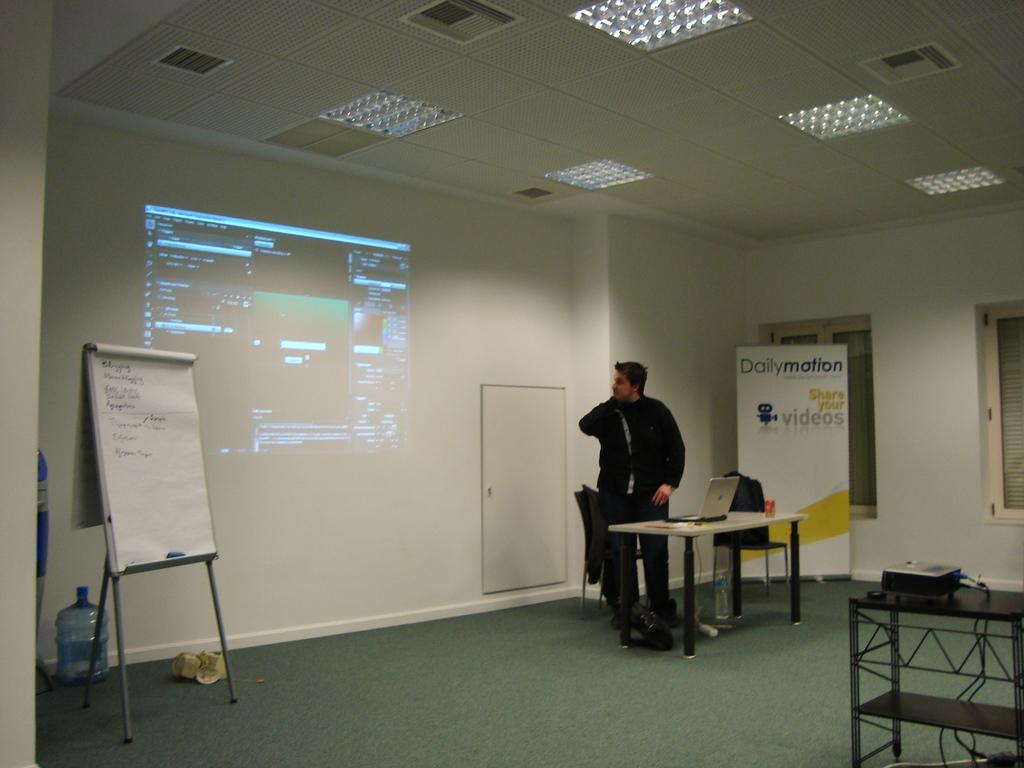<image>
Summarize the visual content of the image. A man stands at the front of a room with a projected computer screen and a Dailymotion poster board behind him 